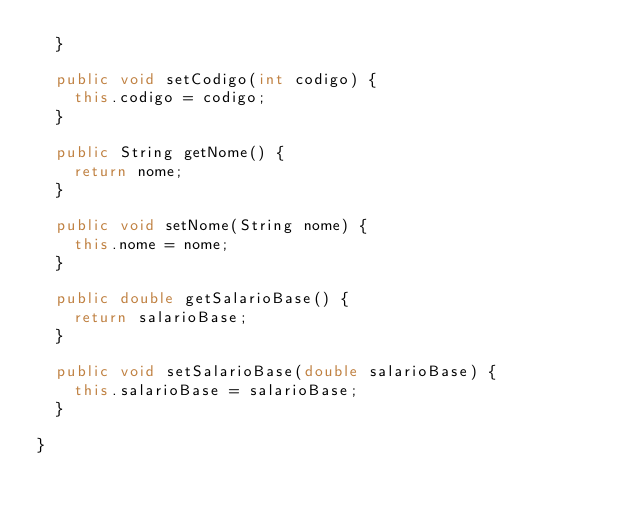Convert code to text. <code><loc_0><loc_0><loc_500><loc_500><_Java_>	}

	public void setCodigo(int codigo) {
		this.codigo = codigo;
	}

	public String getNome() {
		return nome;
	}

	public void setNome(String nome) {
		this.nome = nome;
	}

	public double getSalarioBase() {
		return salarioBase;
	}

	public void setSalarioBase(double salarioBase) {
		this.salarioBase = salarioBase;
	}

}
</code> 